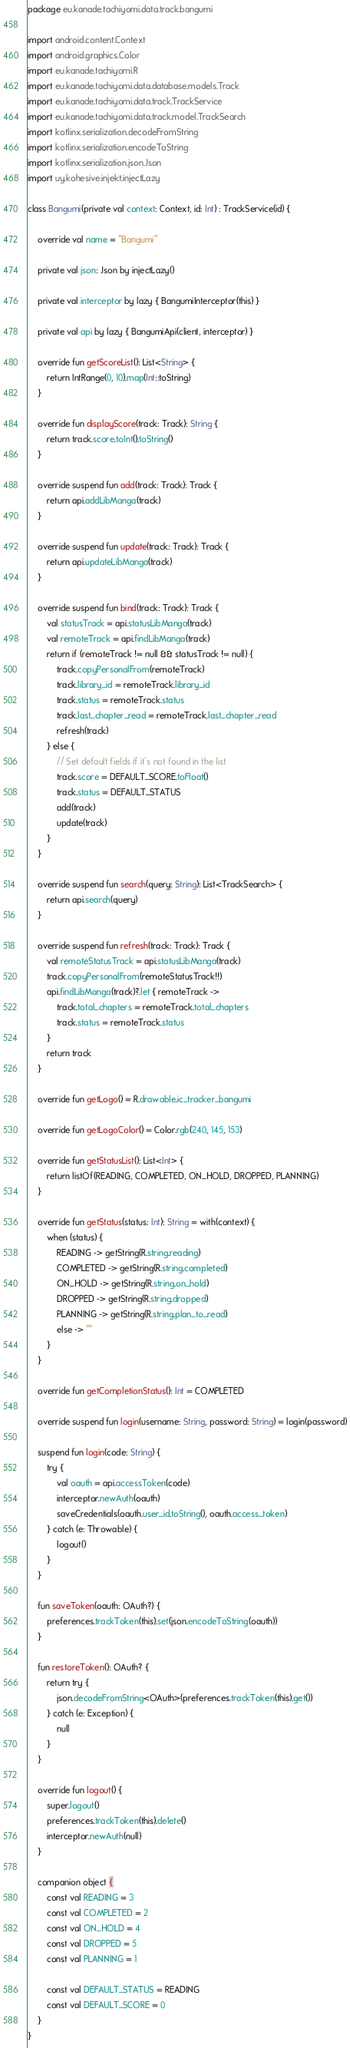<code> <loc_0><loc_0><loc_500><loc_500><_Kotlin_>package eu.kanade.tachiyomi.data.track.bangumi

import android.content.Context
import android.graphics.Color
import eu.kanade.tachiyomi.R
import eu.kanade.tachiyomi.data.database.models.Track
import eu.kanade.tachiyomi.data.track.TrackService
import eu.kanade.tachiyomi.data.track.model.TrackSearch
import kotlinx.serialization.decodeFromString
import kotlinx.serialization.encodeToString
import kotlinx.serialization.json.Json
import uy.kohesive.injekt.injectLazy

class Bangumi(private val context: Context, id: Int) : TrackService(id) {

    override val name = "Bangumi"

    private val json: Json by injectLazy()

    private val interceptor by lazy { BangumiInterceptor(this) }

    private val api by lazy { BangumiApi(client, interceptor) }

    override fun getScoreList(): List<String> {
        return IntRange(0, 10).map(Int::toString)
    }

    override fun displayScore(track: Track): String {
        return track.score.toInt().toString()
    }

    override suspend fun add(track: Track): Track {
        return api.addLibManga(track)
    }

    override suspend fun update(track: Track): Track {
        return api.updateLibManga(track)
    }

    override suspend fun bind(track: Track): Track {
        val statusTrack = api.statusLibManga(track)
        val remoteTrack = api.findLibManga(track)
        return if (remoteTrack != null && statusTrack != null) {
            track.copyPersonalFrom(remoteTrack)
            track.library_id = remoteTrack.library_id
            track.status = remoteTrack.status
            track.last_chapter_read = remoteTrack.last_chapter_read
            refresh(track)
        } else {
            // Set default fields if it's not found in the list
            track.score = DEFAULT_SCORE.toFloat()
            track.status = DEFAULT_STATUS
            add(track)
            update(track)
        }
    }

    override suspend fun search(query: String): List<TrackSearch> {
        return api.search(query)
    }

    override suspend fun refresh(track: Track): Track {
        val remoteStatusTrack = api.statusLibManga(track)
        track.copyPersonalFrom(remoteStatusTrack!!)
        api.findLibManga(track)?.let { remoteTrack ->
            track.total_chapters = remoteTrack.total_chapters
            track.status = remoteTrack.status
        }
        return track
    }

    override fun getLogo() = R.drawable.ic_tracker_bangumi

    override fun getLogoColor() = Color.rgb(240, 145, 153)

    override fun getStatusList(): List<Int> {
        return listOf(READING, COMPLETED, ON_HOLD, DROPPED, PLANNING)
    }

    override fun getStatus(status: Int): String = with(context) {
        when (status) {
            READING -> getString(R.string.reading)
            COMPLETED -> getString(R.string.completed)
            ON_HOLD -> getString(R.string.on_hold)
            DROPPED -> getString(R.string.dropped)
            PLANNING -> getString(R.string.plan_to_read)
            else -> ""
        }
    }

    override fun getCompletionStatus(): Int = COMPLETED

    override suspend fun login(username: String, password: String) = login(password)

    suspend fun login(code: String) {
        try {
            val oauth = api.accessToken(code)
            interceptor.newAuth(oauth)
            saveCredentials(oauth.user_id.toString(), oauth.access_token)
        } catch (e: Throwable) {
            logout()
        }
    }

    fun saveToken(oauth: OAuth?) {
        preferences.trackToken(this).set(json.encodeToString(oauth))
    }

    fun restoreToken(): OAuth? {
        return try {
            json.decodeFromString<OAuth>(preferences.trackToken(this).get())
        } catch (e: Exception) {
            null
        }
    }

    override fun logout() {
        super.logout()
        preferences.trackToken(this).delete()
        interceptor.newAuth(null)
    }

    companion object {
        const val READING = 3
        const val COMPLETED = 2
        const val ON_HOLD = 4
        const val DROPPED = 5
        const val PLANNING = 1

        const val DEFAULT_STATUS = READING
        const val DEFAULT_SCORE = 0
    }
}
</code> 